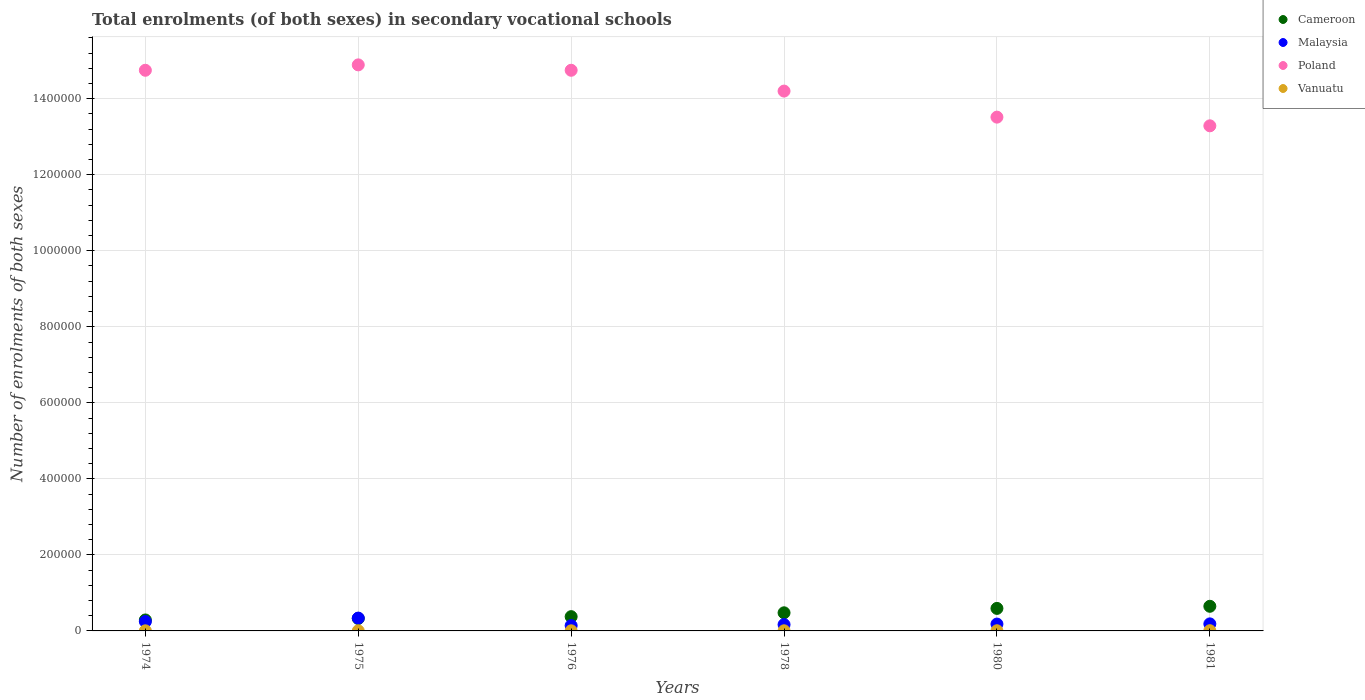How many different coloured dotlines are there?
Make the answer very short. 4. What is the number of enrolments in secondary schools in Poland in 1976?
Give a very brief answer. 1.47e+06. Across all years, what is the maximum number of enrolments in secondary schools in Poland?
Provide a short and direct response. 1.49e+06. Across all years, what is the minimum number of enrolments in secondary schools in Cameroon?
Ensure brevity in your answer.  2.88e+04. In which year was the number of enrolments in secondary schools in Malaysia maximum?
Your response must be concise. 1975. What is the total number of enrolments in secondary schools in Malaysia in the graph?
Provide a succinct answer. 1.26e+05. What is the difference between the number of enrolments in secondary schools in Vanuatu in 1975 and that in 1980?
Offer a very short reply. -214. What is the difference between the number of enrolments in secondary schools in Malaysia in 1981 and the number of enrolments in secondary schools in Cameroon in 1974?
Provide a short and direct response. -1.03e+04. What is the average number of enrolments in secondary schools in Cameroon per year?
Offer a terse response. 4.51e+04. In the year 1978, what is the difference between the number of enrolments in secondary schools in Poland and number of enrolments in secondary schools in Cameroon?
Provide a succinct answer. 1.37e+06. What is the ratio of the number of enrolments in secondary schools in Cameroon in 1978 to that in 1980?
Keep it short and to the point. 0.8. Is the number of enrolments in secondary schools in Malaysia in 1974 less than that in 1976?
Make the answer very short. No. Is the difference between the number of enrolments in secondary schools in Poland in 1975 and 1978 greater than the difference between the number of enrolments in secondary schools in Cameroon in 1975 and 1978?
Your answer should be compact. Yes. What is the difference between the highest and the second highest number of enrolments in secondary schools in Malaysia?
Make the answer very short. 9101. What is the difference between the highest and the lowest number of enrolments in secondary schools in Poland?
Offer a terse response. 1.60e+05. Is the sum of the number of enrolments in secondary schools in Cameroon in 1974 and 1976 greater than the maximum number of enrolments in secondary schools in Vanuatu across all years?
Your answer should be compact. Yes. Is it the case that in every year, the sum of the number of enrolments in secondary schools in Poland and number of enrolments in secondary schools in Malaysia  is greater than the sum of number of enrolments in secondary schools in Vanuatu and number of enrolments in secondary schools in Cameroon?
Offer a terse response. Yes. Does the number of enrolments in secondary schools in Vanuatu monotonically increase over the years?
Your answer should be compact. No. Is the number of enrolments in secondary schools in Cameroon strictly greater than the number of enrolments in secondary schools in Malaysia over the years?
Provide a succinct answer. No. Is the number of enrolments in secondary schools in Vanuatu strictly less than the number of enrolments in secondary schools in Poland over the years?
Provide a succinct answer. Yes. How many dotlines are there?
Give a very brief answer. 4. Does the graph contain any zero values?
Offer a very short reply. No. Does the graph contain grids?
Ensure brevity in your answer.  Yes. Where does the legend appear in the graph?
Your answer should be very brief. Top right. How are the legend labels stacked?
Provide a succinct answer. Vertical. What is the title of the graph?
Provide a short and direct response. Total enrolments (of both sexes) in secondary vocational schools. What is the label or title of the X-axis?
Make the answer very short. Years. What is the label or title of the Y-axis?
Your answer should be compact. Number of enrolments of both sexes. What is the Number of enrolments of both sexes in Cameroon in 1974?
Provide a short and direct response. 2.88e+04. What is the Number of enrolments of both sexes of Malaysia in 1974?
Offer a terse response. 2.46e+04. What is the Number of enrolments of both sexes in Poland in 1974?
Your answer should be compact. 1.47e+06. What is the Number of enrolments of both sexes of Vanuatu in 1974?
Your response must be concise. 279. What is the Number of enrolments of both sexes in Cameroon in 1975?
Provide a succinct answer. 3.27e+04. What is the Number of enrolments of both sexes of Malaysia in 1975?
Provide a short and direct response. 3.37e+04. What is the Number of enrolments of both sexes in Poland in 1975?
Offer a very short reply. 1.49e+06. What is the Number of enrolments of both sexes of Vanuatu in 1975?
Offer a very short reply. 242. What is the Number of enrolments of both sexes of Cameroon in 1976?
Ensure brevity in your answer.  3.75e+04. What is the Number of enrolments of both sexes of Malaysia in 1976?
Give a very brief answer. 1.40e+04. What is the Number of enrolments of both sexes of Poland in 1976?
Provide a short and direct response. 1.47e+06. What is the Number of enrolments of both sexes of Vanuatu in 1976?
Your response must be concise. 308. What is the Number of enrolments of both sexes of Cameroon in 1978?
Your response must be concise. 4.77e+04. What is the Number of enrolments of both sexes of Malaysia in 1978?
Give a very brief answer. 1.67e+04. What is the Number of enrolments of both sexes of Poland in 1978?
Provide a succinct answer. 1.42e+06. What is the Number of enrolments of both sexes of Vanuatu in 1978?
Provide a succinct answer. 363. What is the Number of enrolments of both sexes in Cameroon in 1980?
Provide a short and direct response. 5.92e+04. What is the Number of enrolments of both sexes of Malaysia in 1980?
Provide a succinct answer. 1.80e+04. What is the Number of enrolments of both sexes of Poland in 1980?
Make the answer very short. 1.35e+06. What is the Number of enrolments of both sexes in Vanuatu in 1980?
Your answer should be very brief. 456. What is the Number of enrolments of both sexes of Cameroon in 1981?
Keep it short and to the point. 6.48e+04. What is the Number of enrolments of both sexes in Malaysia in 1981?
Offer a terse response. 1.85e+04. What is the Number of enrolments of both sexes in Poland in 1981?
Provide a short and direct response. 1.33e+06. What is the Number of enrolments of both sexes of Vanuatu in 1981?
Offer a very short reply. 597. Across all years, what is the maximum Number of enrolments of both sexes of Cameroon?
Offer a very short reply. 6.48e+04. Across all years, what is the maximum Number of enrolments of both sexes of Malaysia?
Your answer should be very brief. 3.37e+04. Across all years, what is the maximum Number of enrolments of both sexes in Poland?
Provide a succinct answer. 1.49e+06. Across all years, what is the maximum Number of enrolments of both sexes of Vanuatu?
Ensure brevity in your answer.  597. Across all years, what is the minimum Number of enrolments of both sexes in Cameroon?
Give a very brief answer. 2.88e+04. Across all years, what is the minimum Number of enrolments of both sexes of Malaysia?
Provide a short and direct response. 1.40e+04. Across all years, what is the minimum Number of enrolments of both sexes of Poland?
Provide a short and direct response. 1.33e+06. Across all years, what is the minimum Number of enrolments of both sexes in Vanuatu?
Your answer should be very brief. 242. What is the total Number of enrolments of both sexes of Cameroon in the graph?
Provide a succinct answer. 2.71e+05. What is the total Number of enrolments of both sexes in Malaysia in the graph?
Offer a terse response. 1.26e+05. What is the total Number of enrolments of both sexes of Poland in the graph?
Offer a terse response. 8.54e+06. What is the total Number of enrolments of both sexes in Vanuatu in the graph?
Make the answer very short. 2245. What is the difference between the Number of enrolments of both sexes in Cameroon in 1974 and that in 1975?
Your answer should be compact. -3887. What is the difference between the Number of enrolments of both sexes of Malaysia in 1974 and that in 1975?
Your response must be concise. -9101. What is the difference between the Number of enrolments of both sexes in Poland in 1974 and that in 1975?
Provide a succinct answer. -1.42e+04. What is the difference between the Number of enrolments of both sexes of Cameroon in 1974 and that in 1976?
Keep it short and to the point. -8713. What is the difference between the Number of enrolments of both sexes in Malaysia in 1974 and that in 1976?
Your response must be concise. 1.06e+04. What is the difference between the Number of enrolments of both sexes of Cameroon in 1974 and that in 1978?
Your response must be concise. -1.88e+04. What is the difference between the Number of enrolments of both sexes in Malaysia in 1974 and that in 1978?
Your answer should be very brief. 7990. What is the difference between the Number of enrolments of both sexes of Poland in 1974 and that in 1978?
Keep it short and to the point. 5.48e+04. What is the difference between the Number of enrolments of both sexes in Vanuatu in 1974 and that in 1978?
Give a very brief answer. -84. What is the difference between the Number of enrolments of both sexes of Cameroon in 1974 and that in 1980?
Your answer should be compact. -3.04e+04. What is the difference between the Number of enrolments of both sexes of Malaysia in 1974 and that in 1980?
Offer a very short reply. 6610. What is the difference between the Number of enrolments of both sexes in Poland in 1974 and that in 1980?
Ensure brevity in your answer.  1.23e+05. What is the difference between the Number of enrolments of both sexes in Vanuatu in 1974 and that in 1980?
Your answer should be very brief. -177. What is the difference between the Number of enrolments of both sexes of Cameroon in 1974 and that in 1981?
Ensure brevity in your answer.  -3.60e+04. What is the difference between the Number of enrolments of both sexes in Malaysia in 1974 and that in 1981?
Your answer should be very brief. 6120. What is the difference between the Number of enrolments of both sexes in Poland in 1974 and that in 1981?
Keep it short and to the point. 1.46e+05. What is the difference between the Number of enrolments of both sexes in Vanuatu in 1974 and that in 1981?
Offer a very short reply. -318. What is the difference between the Number of enrolments of both sexes in Cameroon in 1975 and that in 1976?
Your answer should be compact. -4826. What is the difference between the Number of enrolments of both sexes of Malaysia in 1975 and that in 1976?
Provide a short and direct response. 1.97e+04. What is the difference between the Number of enrolments of both sexes of Poland in 1975 and that in 1976?
Keep it short and to the point. 1.42e+04. What is the difference between the Number of enrolments of both sexes of Vanuatu in 1975 and that in 1976?
Offer a very short reply. -66. What is the difference between the Number of enrolments of both sexes of Cameroon in 1975 and that in 1978?
Provide a short and direct response. -1.49e+04. What is the difference between the Number of enrolments of both sexes in Malaysia in 1975 and that in 1978?
Give a very brief answer. 1.71e+04. What is the difference between the Number of enrolments of both sexes in Poland in 1975 and that in 1978?
Offer a very short reply. 6.90e+04. What is the difference between the Number of enrolments of both sexes in Vanuatu in 1975 and that in 1978?
Ensure brevity in your answer.  -121. What is the difference between the Number of enrolments of both sexes in Cameroon in 1975 and that in 1980?
Ensure brevity in your answer.  -2.65e+04. What is the difference between the Number of enrolments of both sexes in Malaysia in 1975 and that in 1980?
Keep it short and to the point. 1.57e+04. What is the difference between the Number of enrolments of both sexes in Poland in 1975 and that in 1980?
Offer a terse response. 1.37e+05. What is the difference between the Number of enrolments of both sexes of Vanuatu in 1975 and that in 1980?
Give a very brief answer. -214. What is the difference between the Number of enrolments of both sexes of Cameroon in 1975 and that in 1981?
Your response must be concise. -3.21e+04. What is the difference between the Number of enrolments of both sexes of Malaysia in 1975 and that in 1981?
Make the answer very short. 1.52e+04. What is the difference between the Number of enrolments of both sexes of Poland in 1975 and that in 1981?
Your answer should be very brief. 1.60e+05. What is the difference between the Number of enrolments of both sexes in Vanuatu in 1975 and that in 1981?
Offer a very short reply. -355. What is the difference between the Number of enrolments of both sexes in Cameroon in 1976 and that in 1978?
Your answer should be compact. -1.01e+04. What is the difference between the Number of enrolments of both sexes in Malaysia in 1976 and that in 1978?
Provide a succinct answer. -2651. What is the difference between the Number of enrolments of both sexes in Poland in 1976 and that in 1978?
Provide a short and direct response. 5.48e+04. What is the difference between the Number of enrolments of both sexes in Vanuatu in 1976 and that in 1978?
Give a very brief answer. -55. What is the difference between the Number of enrolments of both sexes of Cameroon in 1976 and that in 1980?
Your response must be concise. -2.17e+04. What is the difference between the Number of enrolments of both sexes in Malaysia in 1976 and that in 1980?
Keep it short and to the point. -4031. What is the difference between the Number of enrolments of both sexes of Poland in 1976 and that in 1980?
Your answer should be very brief. 1.23e+05. What is the difference between the Number of enrolments of both sexes in Vanuatu in 1976 and that in 1980?
Ensure brevity in your answer.  -148. What is the difference between the Number of enrolments of both sexes in Cameroon in 1976 and that in 1981?
Your answer should be compact. -2.72e+04. What is the difference between the Number of enrolments of both sexes of Malaysia in 1976 and that in 1981?
Provide a succinct answer. -4521. What is the difference between the Number of enrolments of both sexes in Poland in 1976 and that in 1981?
Offer a very short reply. 1.46e+05. What is the difference between the Number of enrolments of both sexes in Vanuatu in 1976 and that in 1981?
Give a very brief answer. -289. What is the difference between the Number of enrolments of both sexes of Cameroon in 1978 and that in 1980?
Keep it short and to the point. -1.16e+04. What is the difference between the Number of enrolments of both sexes in Malaysia in 1978 and that in 1980?
Offer a very short reply. -1380. What is the difference between the Number of enrolments of both sexes in Poland in 1978 and that in 1980?
Provide a succinct answer. 6.85e+04. What is the difference between the Number of enrolments of both sexes in Vanuatu in 1978 and that in 1980?
Offer a terse response. -93. What is the difference between the Number of enrolments of both sexes in Cameroon in 1978 and that in 1981?
Offer a very short reply. -1.71e+04. What is the difference between the Number of enrolments of both sexes of Malaysia in 1978 and that in 1981?
Your response must be concise. -1870. What is the difference between the Number of enrolments of both sexes of Poland in 1978 and that in 1981?
Your response must be concise. 9.14e+04. What is the difference between the Number of enrolments of both sexes in Vanuatu in 1978 and that in 1981?
Keep it short and to the point. -234. What is the difference between the Number of enrolments of both sexes of Cameroon in 1980 and that in 1981?
Your answer should be compact. -5550. What is the difference between the Number of enrolments of both sexes of Malaysia in 1980 and that in 1981?
Provide a succinct answer. -490. What is the difference between the Number of enrolments of both sexes in Poland in 1980 and that in 1981?
Give a very brief answer. 2.28e+04. What is the difference between the Number of enrolments of both sexes of Vanuatu in 1980 and that in 1981?
Ensure brevity in your answer.  -141. What is the difference between the Number of enrolments of both sexes in Cameroon in 1974 and the Number of enrolments of both sexes in Malaysia in 1975?
Keep it short and to the point. -4909. What is the difference between the Number of enrolments of both sexes of Cameroon in 1974 and the Number of enrolments of both sexes of Poland in 1975?
Your response must be concise. -1.46e+06. What is the difference between the Number of enrolments of both sexes in Cameroon in 1974 and the Number of enrolments of both sexes in Vanuatu in 1975?
Keep it short and to the point. 2.86e+04. What is the difference between the Number of enrolments of both sexes in Malaysia in 1974 and the Number of enrolments of both sexes in Poland in 1975?
Keep it short and to the point. -1.46e+06. What is the difference between the Number of enrolments of both sexes of Malaysia in 1974 and the Number of enrolments of both sexes of Vanuatu in 1975?
Your answer should be very brief. 2.44e+04. What is the difference between the Number of enrolments of both sexes in Poland in 1974 and the Number of enrolments of both sexes in Vanuatu in 1975?
Give a very brief answer. 1.47e+06. What is the difference between the Number of enrolments of both sexes in Cameroon in 1974 and the Number of enrolments of both sexes in Malaysia in 1976?
Your answer should be very brief. 1.48e+04. What is the difference between the Number of enrolments of both sexes in Cameroon in 1974 and the Number of enrolments of both sexes in Poland in 1976?
Offer a very short reply. -1.45e+06. What is the difference between the Number of enrolments of both sexes in Cameroon in 1974 and the Number of enrolments of both sexes in Vanuatu in 1976?
Provide a short and direct response. 2.85e+04. What is the difference between the Number of enrolments of both sexes of Malaysia in 1974 and the Number of enrolments of both sexes of Poland in 1976?
Keep it short and to the point. -1.45e+06. What is the difference between the Number of enrolments of both sexes in Malaysia in 1974 and the Number of enrolments of both sexes in Vanuatu in 1976?
Your response must be concise. 2.43e+04. What is the difference between the Number of enrolments of both sexes of Poland in 1974 and the Number of enrolments of both sexes of Vanuatu in 1976?
Provide a short and direct response. 1.47e+06. What is the difference between the Number of enrolments of both sexes in Cameroon in 1974 and the Number of enrolments of both sexes in Malaysia in 1978?
Your answer should be very brief. 1.22e+04. What is the difference between the Number of enrolments of both sexes of Cameroon in 1974 and the Number of enrolments of both sexes of Poland in 1978?
Your answer should be very brief. -1.39e+06. What is the difference between the Number of enrolments of both sexes of Cameroon in 1974 and the Number of enrolments of both sexes of Vanuatu in 1978?
Your answer should be very brief. 2.85e+04. What is the difference between the Number of enrolments of both sexes in Malaysia in 1974 and the Number of enrolments of both sexes in Poland in 1978?
Your answer should be very brief. -1.40e+06. What is the difference between the Number of enrolments of both sexes in Malaysia in 1974 and the Number of enrolments of both sexes in Vanuatu in 1978?
Your answer should be very brief. 2.43e+04. What is the difference between the Number of enrolments of both sexes of Poland in 1974 and the Number of enrolments of both sexes of Vanuatu in 1978?
Your response must be concise. 1.47e+06. What is the difference between the Number of enrolments of both sexes in Cameroon in 1974 and the Number of enrolments of both sexes in Malaysia in 1980?
Make the answer very short. 1.08e+04. What is the difference between the Number of enrolments of both sexes in Cameroon in 1974 and the Number of enrolments of both sexes in Poland in 1980?
Give a very brief answer. -1.32e+06. What is the difference between the Number of enrolments of both sexes in Cameroon in 1974 and the Number of enrolments of both sexes in Vanuatu in 1980?
Make the answer very short. 2.84e+04. What is the difference between the Number of enrolments of both sexes of Malaysia in 1974 and the Number of enrolments of both sexes of Poland in 1980?
Provide a short and direct response. -1.33e+06. What is the difference between the Number of enrolments of both sexes in Malaysia in 1974 and the Number of enrolments of both sexes in Vanuatu in 1980?
Provide a succinct answer. 2.42e+04. What is the difference between the Number of enrolments of both sexes of Poland in 1974 and the Number of enrolments of both sexes of Vanuatu in 1980?
Provide a short and direct response. 1.47e+06. What is the difference between the Number of enrolments of both sexes in Cameroon in 1974 and the Number of enrolments of both sexes in Malaysia in 1981?
Provide a short and direct response. 1.03e+04. What is the difference between the Number of enrolments of both sexes of Cameroon in 1974 and the Number of enrolments of both sexes of Poland in 1981?
Give a very brief answer. -1.30e+06. What is the difference between the Number of enrolments of both sexes in Cameroon in 1974 and the Number of enrolments of both sexes in Vanuatu in 1981?
Ensure brevity in your answer.  2.82e+04. What is the difference between the Number of enrolments of both sexes in Malaysia in 1974 and the Number of enrolments of both sexes in Poland in 1981?
Your answer should be compact. -1.30e+06. What is the difference between the Number of enrolments of both sexes in Malaysia in 1974 and the Number of enrolments of both sexes in Vanuatu in 1981?
Provide a succinct answer. 2.40e+04. What is the difference between the Number of enrolments of both sexes of Poland in 1974 and the Number of enrolments of both sexes of Vanuatu in 1981?
Offer a very short reply. 1.47e+06. What is the difference between the Number of enrolments of both sexes of Cameroon in 1975 and the Number of enrolments of both sexes of Malaysia in 1976?
Provide a short and direct response. 1.87e+04. What is the difference between the Number of enrolments of both sexes in Cameroon in 1975 and the Number of enrolments of both sexes in Poland in 1976?
Provide a succinct answer. -1.44e+06. What is the difference between the Number of enrolments of both sexes in Cameroon in 1975 and the Number of enrolments of both sexes in Vanuatu in 1976?
Your answer should be very brief. 3.24e+04. What is the difference between the Number of enrolments of both sexes of Malaysia in 1975 and the Number of enrolments of both sexes of Poland in 1976?
Keep it short and to the point. -1.44e+06. What is the difference between the Number of enrolments of both sexes of Malaysia in 1975 and the Number of enrolments of both sexes of Vanuatu in 1976?
Give a very brief answer. 3.34e+04. What is the difference between the Number of enrolments of both sexes in Poland in 1975 and the Number of enrolments of both sexes in Vanuatu in 1976?
Provide a succinct answer. 1.49e+06. What is the difference between the Number of enrolments of both sexes of Cameroon in 1975 and the Number of enrolments of both sexes of Malaysia in 1978?
Your answer should be very brief. 1.61e+04. What is the difference between the Number of enrolments of both sexes in Cameroon in 1975 and the Number of enrolments of both sexes in Poland in 1978?
Offer a terse response. -1.39e+06. What is the difference between the Number of enrolments of both sexes in Cameroon in 1975 and the Number of enrolments of both sexes in Vanuatu in 1978?
Provide a succinct answer. 3.24e+04. What is the difference between the Number of enrolments of both sexes of Malaysia in 1975 and the Number of enrolments of both sexes of Poland in 1978?
Make the answer very short. -1.39e+06. What is the difference between the Number of enrolments of both sexes of Malaysia in 1975 and the Number of enrolments of both sexes of Vanuatu in 1978?
Ensure brevity in your answer.  3.34e+04. What is the difference between the Number of enrolments of both sexes of Poland in 1975 and the Number of enrolments of both sexes of Vanuatu in 1978?
Make the answer very short. 1.49e+06. What is the difference between the Number of enrolments of both sexes in Cameroon in 1975 and the Number of enrolments of both sexes in Malaysia in 1980?
Your response must be concise. 1.47e+04. What is the difference between the Number of enrolments of both sexes of Cameroon in 1975 and the Number of enrolments of both sexes of Poland in 1980?
Provide a short and direct response. -1.32e+06. What is the difference between the Number of enrolments of both sexes in Cameroon in 1975 and the Number of enrolments of both sexes in Vanuatu in 1980?
Offer a terse response. 3.23e+04. What is the difference between the Number of enrolments of both sexes of Malaysia in 1975 and the Number of enrolments of both sexes of Poland in 1980?
Offer a terse response. -1.32e+06. What is the difference between the Number of enrolments of both sexes in Malaysia in 1975 and the Number of enrolments of both sexes in Vanuatu in 1980?
Provide a short and direct response. 3.33e+04. What is the difference between the Number of enrolments of both sexes in Poland in 1975 and the Number of enrolments of both sexes in Vanuatu in 1980?
Provide a succinct answer. 1.49e+06. What is the difference between the Number of enrolments of both sexes of Cameroon in 1975 and the Number of enrolments of both sexes of Malaysia in 1981?
Your answer should be compact. 1.42e+04. What is the difference between the Number of enrolments of both sexes in Cameroon in 1975 and the Number of enrolments of both sexes in Poland in 1981?
Give a very brief answer. -1.30e+06. What is the difference between the Number of enrolments of both sexes of Cameroon in 1975 and the Number of enrolments of both sexes of Vanuatu in 1981?
Provide a succinct answer. 3.21e+04. What is the difference between the Number of enrolments of both sexes of Malaysia in 1975 and the Number of enrolments of both sexes of Poland in 1981?
Offer a very short reply. -1.29e+06. What is the difference between the Number of enrolments of both sexes in Malaysia in 1975 and the Number of enrolments of both sexes in Vanuatu in 1981?
Your response must be concise. 3.31e+04. What is the difference between the Number of enrolments of both sexes in Poland in 1975 and the Number of enrolments of both sexes in Vanuatu in 1981?
Your response must be concise. 1.49e+06. What is the difference between the Number of enrolments of both sexes of Cameroon in 1976 and the Number of enrolments of both sexes of Malaysia in 1978?
Give a very brief answer. 2.09e+04. What is the difference between the Number of enrolments of both sexes of Cameroon in 1976 and the Number of enrolments of both sexes of Poland in 1978?
Provide a succinct answer. -1.38e+06. What is the difference between the Number of enrolments of both sexes of Cameroon in 1976 and the Number of enrolments of both sexes of Vanuatu in 1978?
Your answer should be compact. 3.72e+04. What is the difference between the Number of enrolments of both sexes of Malaysia in 1976 and the Number of enrolments of both sexes of Poland in 1978?
Offer a terse response. -1.41e+06. What is the difference between the Number of enrolments of both sexes of Malaysia in 1976 and the Number of enrolments of both sexes of Vanuatu in 1978?
Give a very brief answer. 1.36e+04. What is the difference between the Number of enrolments of both sexes in Poland in 1976 and the Number of enrolments of both sexes in Vanuatu in 1978?
Offer a terse response. 1.47e+06. What is the difference between the Number of enrolments of both sexes of Cameroon in 1976 and the Number of enrolments of both sexes of Malaysia in 1980?
Provide a succinct answer. 1.95e+04. What is the difference between the Number of enrolments of both sexes in Cameroon in 1976 and the Number of enrolments of both sexes in Poland in 1980?
Offer a very short reply. -1.31e+06. What is the difference between the Number of enrolments of both sexes of Cameroon in 1976 and the Number of enrolments of both sexes of Vanuatu in 1980?
Offer a very short reply. 3.71e+04. What is the difference between the Number of enrolments of both sexes of Malaysia in 1976 and the Number of enrolments of both sexes of Poland in 1980?
Offer a very short reply. -1.34e+06. What is the difference between the Number of enrolments of both sexes of Malaysia in 1976 and the Number of enrolments of both sexes of Vanuatu in 1980?
Keep it short and to the point. 1.35e+04. What is the difference between the Number of enrolments of both sexes of Poland in 1976 and the Number of enrolments of both sexes of Vanuatu in 1980?
Your answer should be compact. 1.47e+06. What is the difference between the Number of enrolments of both sexes in Cameroon in 1976 and the Number of enrolments of both sexes in Malaysia in 1981?
Make the answer very short. 1.90e+04. What is the difference between the Number of enrolments of both sexes in Cameroon in 1976 and the Number of enrolments of both sexes in Poland in 1981?
Make the answer very short. -1.29e+06. What is the difference between the Number of enrolments of both sexes in Cameroon in 1976 and the Number of enrolments of both sexes in Vanuatu in 1981?
Provide a succinct answer. 3.69e+04. What is the difference between the Number of enrolments of both sexes in Malaysia in 1976 and the Number of enrolments of both sexes in Poland in 1981?
Your answer should be compact. -1.31e+06. What is the difference between the Number of enrolments of both sexes of Malaysia in 1976 and the Number of enrolments of both sexes of Vanuatu in 1981?
Provide a succinct answer. 1.34e+04. What is the difference between the Number of enrolments of both sexes of Poland in 1976 and the Number of enrolments of both sexes of Vanuatu in 1981?
Make the answer very short. 1.47e+06. What is the difference between the Number of enrolments of both sexes of Cameroon in 1978 and the Number of enrolments of both sexes of Malaysia in 1980?
Your answer should be very brief. 2.96e+04. What is the difference between the Number of enrolments of both sexes in Cameroon in 1978 and the Number of enrolments of both sexes in Poland in 1980?
Provide a short and direct response. -1.30e+06. What is the difference between the Number of enrolments of both sexes of Cameroon in 1978 and the Number of enrolments of both sexes of Vanuatu in 1980?
Keep it short and to the point. 4.72e+04. What is the difference between the Number of enrolments of both sexes in Malaysia in 1978 and the Number of enrolments of both sexes in Poland in 1980?
Ensure brevity in your answer.  -1.33e+06. What is the difference between the Number of enrolments of both sexes of Malaysia in 1978 and the Number of enrolments of both sexes of Vanuatu in 1980?
Offer a very short reply. 1.62e+04. What is the difference between the Number of enrolments of both sexes of Poland in 1978 and the Number of enrolments of both sexes of Vanuatu in 1980?
Provide a short and direct response. 1.42e+06. What is the difference between the Number of enrolments of both sexes of Cameroon in 1978 and the Number of enrolments of both sexes of Malaysia in 1981?
Ensure brevity in your answer.  2.91e+04. What is the difference between the Number of enrolments of both sexes of Cameroon in 1978 and the Number of enrolments of both sexes of Poland in 1981?
Offer a very short reply. -1.28e+06. What is the difference between the Number of enrolments of both sexes in Cameroon in 1978 and the Number of enrolments of both sexes in Vanuatu in 1981?
Provide a succinct answer. 4.71e+04. What is the difference between the Number of enrolments of both sexes of Malaysia in 1978 and the Number of enrolments of both sexes of Poland in 1981?
Ensure brevity in your answer.  -1.31e+06. What is the difference between the Number of enrolments of both sexes of Malaysia in 1978 and the Number of enrolments of both sexes of Vanuatu in 1981?
Your answer should be compact. 1.61e+04. What is the difference between the Number of enrolments of both sexes in Poland in 1978 and the Number of enrolments of both sexes in Vanuatu in 1981?
Your answer should be compact. 1.42e+06. What is the difference between the Number of enrolments of both sexes of Cameroon in 1980 and the Number of enrolments of both sexes of Malaysia in 1981?
Make the answer very short. 4.07e+04. What is the difference between the Number of enrolments of both sexes in Cameroon in 1980 and the Number of enrolments of both sexes in Poland in 1981?
Your answer should be compact. -1.27e+06. What is the difference between the Number of enrolments of both sexes in Cameroon in 1980 and the Number of enrolments of both sexes in Vanuatu in 1981?
Offer a terse response. 5.86e+04. What is the difference between the Number of enrolments of both sexes in Malaysia in 1980 and the Number of enrolments of both sexes in Poland in 1981?
Make the answer very short. -1.31e+06. What is the difference between the Number of enrolments of both sexes of Malaysia in 1980 and the Number of enrolments of both sexes of Vanuatu in 1981?
Keep it short and to the point. 1.74e+04. What is the difference between the Number of enrolments of both sexes in Poland in 1980 and the Number of enrolments of both sexes in Vanuatu in 1981?
Make the answer very short. 1.35e+06. What is the average Number of enrolments of both sexes of Cameroon per year?
Offer a terse response. 4.51e+04. What is the average Number of enrolments of both sexes of Malaysia per year?
Your response must be concise. 2.09e+04. What is the average Number of enrolments of both sexes of Poland per year?
Give a very brief answer. 1.42e+06. What is the average Number of enrolments of both sexes in Vanuatu per year?
Provide a succinct answer. 374.17. In the year 1974, what is the difference between the Number of enrolments of both sexes in Cameroon and Number of enrolments of both sexes in Malaysia?
Offer a very short reply. 4192. In the year 1974, what is the difference between the Number of enrolments of both sexes in Cameroon and Number of enrolments of both sexes in Poland?
Give a very brief answer. -1.45e+06. In the year 1974, what is the difference between the Number of enrolments of both sexes of Cameroon and Number of enrolments of both sexes of Vanuatu?
Your answer should be very brief. 2.86e+04. In the year 1974, what is the difference between the Number of enrolments of both sexes in Malaysia and Number of enrolments of both sexes in Poland?
Your response must be concise. -1.45e+06. In the year 1974, what is the difference between the Number of enrolments of both sexes in Malaysia and Number of enrolments of both sexes in Vanuatu?
Your response must be concise. 2.44e+04. In the year 1974, what is the difference between the Number of enrolments of both sexes in Poland and Number of enrolments of both sexes in Vanuatu?
Keep it short and to the point. 1.47e+06. In the year 1975, what is the difference between the Number of enrolments of both sexes in Cameroon and Number of enrolments of both sexes in Malaysia?
Keep it short and to the point. -1022. In the year 1975, what is the difference between the Number of enrolments of both sexes of Cameroon and Number of enrolments of both sexes of Poland?
Your answer should be compact. -1.46e+06. In the year 1975, what is the difference between the Number of enrolments of both sexes in Cameroon and Number of enrolments of both sexes in Vanuatu?
Offer a very short reply. 3.25e+04. In the year 1975, what is the difference between the Number of enrolments of both sexes in Malaysia and Number of enrolments of both sexes in Poland?
Keep it short and to the point. -1.46e+06. In the year 1975, what is the difference between the Number of enrolments of both sexes of Malaysia and Number of enrolments of both sexes of Vanuatu?
Provide a succinct answer. 3.35e+04. In the year 1975, what is the difference between the Number of enrolments of both sexes in Poland and Number of enrolments of both sexes in Vanuatu?
Provide a succinct answer. 1.49e+06. In the year 1976, what is the difference between the Number of enrolments of both sexes of Cameroon and Number of enrolments of both sexes of Malaysia?
Provide a succinct answer. 2.35e+04. In the year 1976, what is the difference between the Number of enrolments of both sexes in Cameroon and Number of enrolments of both sexes in Poland?
Provide a short and direct response. -1.44e+06. In the year 1976, what is the difference between the Number of enrolments of both sexes of Cameroon and Number of enrolments of both sexes of Vanuatu?
Provide a succinct answer. 3.72e+04. In the year 1976, what is the difference between the Number of enrolments of both sexes of Malaysia and Number of enrolments of both sexes of Poland?
Your response must be concise. -1.46e+06. In the year 1976, what is the difference between the Number of enrolments of both sexes of Malaysia and Number of enrolments of both sexes of Vanuatu?
Give a very brief answer. 1.37e+04. In the year 1976, what is the difference between the Number of enrolments of both sexes of Poland and Number of enrolments of both sexes of Vanuatu?
Make the answer very short. 1.47e+06. In the year 1978, what is the difference between the Number of enrolments of both sexes in Cameroon and Number of enrolments of both sexes in Malaysia?
Keep it short and to the point. 3.10e+04. In the year 1978, what is the difference between the Number of enrolments of both sexes of Cameroon and Number of enrolments of both sexes of Poland?
Offer a very short reply. -1.37e+06. In the year 1978, what is the difference between the Number of enrolments of both sexes of Cameroon and Number of enrolments of both sexes of Vanuatu?
Make the answer very short. 4.73e+04. In the year 1978, what is the difference between the Number of enrolments of both sexes in Malaysia and Number of enrolments of both sexes in Poland?
Offer a very short reply. -1.40e+06. In the year 1978, what is the difference between the Number of enrolments of both sexes in Malaysia and Number of enrolments of both sexes in Vanuatu?
Make the answer very short. 1.63e+04. In the year 1978, what is the difference between the Number of enrolments of both sexes in Poland and Number of enrolments of both sexes in Vanuatu?
Ensure brevity in your answer.  1.42e+06. In the year 1980, what is the difference between the Number of enrolments of both sexes in Cameroon and Number of enrolments of both sexes in Malaysia?
Ensure brevity in your answer.  4.12e+04. In the year 1980, what is the difference between the Number of enrolments of both sexes of Cameroon and Number of enrolments of both sexes of Poland?
Offer a very short reply. -1.29e+06. In the year 1980, what is the difference between the Number of enrolments of both sexes of Cameroon and Number of enrolments of both sexes of Vanuatu?
Provide a short and direct response. 5.88e+04. In the year 1980, what is the difference between the Number of enrolments of both sexes of Malaysia and Number of enrolments of both sexes of Poland?
Give a very brief answer. -1.33e+06. In the year 1980, what is the difference between the Number of enrolments of both sexes in Malaysia and Number of enrolments of both sexes in Vanuatu?
Offer a very short reply. 1.76e+04. In the year 1980, what is the difference between the Number of enrolments of both sexes in Poland and Number of enrolments of both sexes in Vanuatu?
Your response must be concise. 1.35e+06. In the year 1981, what is the difference between the Number of enrolments of both sexes of Cameroon and Number of enrolments of both sexes of Malaysia?
Offer a very short reply. 4.63e+04. In the year 1981, what is the difference between the Number of enrolments of both sexes in Cameroon and Number of enrolments of both sexes in Poland?
Keep it short and to the point. -1.26e+06. In the year 1981, what is the difference between the Number of enrolments of both sexes of Cameroon and Number of enrolments of both sexes of Vanuatu?
Ensure brevity in your answer.  6.42e+04. In the year 1981, what is the difference between the Number of enrolments of both sexes in Malaysia and Number of enrolments of both sexes in Poland?
Keep it short and to the point. -1.31e+06. In the year 1981, what is the difference between the Number of enrolments of both sexes in Malaysia and Number of enrolments of both sexes in Vanuatu?
Your answer should be compact. 1.79e+04. In the year 1981, what is the difference between the Number of enrolments of both sexes of Poland and Number of enrolments of both sexes of Vanuatu?
Your answer should be very brief. 1.33e+06. What is the ratio of the Number of enrolments of both sexes in Cameroon in 1974 to that in 1975?
Keep it short and to the point. 0.88. What is the ratio of the Number of enrolments of both sexes in Malaysia in 1974 to that in 1975?
Offer a very short reply. 0.73. What is the ratio of the Number of enrolments of both sexes of Vanuatu in 1974 to that in 1975?
Keep it short and to the point. 1.15. What is the ratio of the Number of enrolments of both sexes of Cameroon in 1974 to that in 1976?
Give a very brief answer. 0.77. What is the ratio of the Number of enrolments of both sexes in Malaysia in 1974 to that in 1976?
Your answer should be very brief. 1.76. What is the ratio of the Number of enrolments of both sexes of Vanuatu in 1974 to that in 1976?
Offer a terse response. 0.91. What is the ratio of the Number of enrolments of both sexes of Cameroon in 1974 to that in 1978?
Ensure brevity in your answer.  0.6. What is the ratio of the Number of enrolments of both sexes of Malaysia in 1974 to that in 1978?
Provide a succinct answer. 1.48. What is the ratio of the Number of enrolments of both sexes of Poland in 1974 to that in 1978?
Give a very brief answer. 1.04. What is the ratio of the Number of enrolments of both sexes in Vanuatu in 1974 to that in 1978?
Make the answer very short. 0.77. What is the ratio of the Number of enrolments of both sexes in Cameroon in 1974 to that in 1980?
Offer a very short reply. 0.49. What is the ratio of the Number of enrolments of both sexes in Malaysia in 1974 to that in 1980?
Ensure brevity in your answer.  1.37. What is the ratio of the Number of enrolments of both sexes of Poland in 1974 to that in 1980?
Make the answer very short. 1.09. What is the ratio of the Number of enrolments of both sexes of Vanuatu in 1974 to that in 1980?
Your answer should be very brief. 0.61. What is the ratio of the Number of enrolments of both sexes in Cameroon in 1974 to that in 1981?
Provide a short and direct response. 0.45. What is the ratio of the Number of enrolments of both sexes of Malaysia in 1974 to that in 1981?
Your answer should be very brief. 1.33. What is the ratio of the Number of enrolments of both sexes in Poland in 1974 to that in 1981?
Keep it short and to the point. 1.11. What is the ratio of the Number of enrolments of both sexes of Vanuatu in 1974 to that in 1981?
Keep it short and to the point. 0.47. What is the ratio of the Number of enrolments of both sexes of Cameroon in 1975 to that in 1976?
Keep it short and to the point. 0.87. What is the ratio of the Number of enrolments of both sexes in Malaysia in 1975 to that in 1976?
Offer a very short reply. 2.41. What is the ratio of the Number of enrolments of both sexes in Poland in 1975 to that in 1976?
Offer a terse response. 1.01. What is the ratio of the Number of enrolments of both sexes of Vanuatu in 1975 to that in 1976?
Offer a terse response. 0.79. What is the ratio of the Number of enrolments of both sexes in Cameroon in 1975 to that in 1978?
Offer a terse response. 0.69. What is the ratio of the Number of enrolments of both sexes of Malaysia in 1975 to that in 1978?
Offer a very short reply. 2.03. What is the ratio of the Number of enrolments of both sexes in Poland in 1975 to that in 1978?
Keep it short and to the point. 1.05. What is the ratio of the Number of enrolments of both sexes of Cameroon in 1975 to that in 1980?
Give a very brief answer. 0.55. What is the ratio of the Number of enrolments of both sexes in Malaysia in 1975 to that in 1980?
Provide a short and direct response. 1.87. What is the ratio of the Number of enrolments of both sexes of Poland in 1975 to that in 1980?
Offer a very short reply. 1.1. What is the ratio of the Number of enrolments of both sexes in Vanuatu in 1975 to that in 1980?
Your response must be concise. 0.53. What is the ratio of the Number of enrolments of both sexes in Cameroon in 1975 to that in 1981?
Provide a short and direct response. 0.51. What is the ratio of the Number of enrolments of both sexes in Malaysia in 1975 to that in 1981?
Your answer should be very brief. 1.82. What is the ratio of the Number of enrolments of both sexes in Poland in 1975 to that in 1981?
Provide a succinct answer. 1.12. What is the ratio of the Number of enrolments of both sexes of Vanuatu in 1975 to that in 1981?
Keep it short and to the point. 0.41. What is the ratio of the Number of enrolments of both sexes in Cameroon in 1976 to that in 1978?
Make the answer very short. 0.79. What is the ratio of the Number of enrolments of both sexes of Malaysia in 1976 to that in 1978?
Provide a succinct answer. 0.84. What is the ratio of the Number of enrolments of both sexes of Poland in 1976 to that in 1978?
Your answer should be very brief. 1.04. What is the ratio of the Number of enrolments of both sexes of Vanuatu in 1976 to that in 1978?
Offer a very short reply. 0.85. What is the ratio of the Number of enrolments of both sexes in Cameroon in 1976 to that in 1980?
Your answer should be compact. 0.63. What is the ratio of the Number of enrolments of both sexes of Malaysia in 1976 to that in 1980?
Make the answer very short. 0.78. What is the ratio of the Number of enrolments of both sexes in Poland in 1976 to that in 1980?
Offer a terse response. 1.09. What is the ratio of the Number of enrolments of both sexes of Vanuatu in 1976 to that in 1980?
Your response must be concise. 0.68. What is the ratio of the Number of enrolments of both sexes in Cameroon in 1976 to that in 1981?
Your answer should be compact. 0.58. What is the ratio of the Number of enrolments of both sexes of Malaysia in 1976 to that in 1981?
Your answer should be very brief. 0.76. What is the ratio of the Number of enrolments of both sexes of Poland in 1976 to that in 1981?
Your answer should be compact. 1.11. What is the ratio of the Number of enrolments of both sexes in Vanuatu in 1976 to that in 1981?
Give a very brief answer. 0.52. What is the ratio of the Number of enrolments of both sexes of Cameroon in 1978 to that in 1980?
Provide a short and direct response. 0.8. What is the ratio of the Number of enrolments of both sexes in Malaysia in 1978 to that in 1980?
Provide a short and direct response. 0.92. What is the ratio of the Number of enrolments of both sexes in Poland in 1978 to that in 1980?
Make the answer very short. 1.05. What is the ratio of the Number of enrolments of both sexes in Vanuatu in 1978 to that in 1980?
Provide a succinct answer. 0.8. What is the ratio of the Number of enrolments of both sexes in Cameroon in 1978 to that in 1981?
Ensure brevity in your answer.  0.74. What is the ratio of the Number of enrolments of both sexes in Malaysia in 1978 to that in 1981?
Give a very brief answer. 0.9. What is the ratio of the Number of enrolments of both sexes of Poland in 1978 to that in 1981?
Make the answer very short. 1.07. What is the ratio of the Number of enrolments of both sexes in Vanuatu in 1978 to that in 1981?
Your response must be concise. 0.61. What is the ratio of the Number of enrolments of both sexes of Cameroon in 1980 to that in 1981?
Your answer should be very brief. 0.91. What is the ratio of the Number of enrolments of both sexes in Malaysia in 1980 to that in 1981?
Offer a very short reply. 0.97. What is the ratio of the Number of enrolments of both sexes of Poland in 1980 to that in 1981?
Ensure brevity in your answer.  1.02. What is the ratio of the Number of enrolments of both sexes in Vanuatu in 1980 to that in 1981?
Provide a short and direct response. 0.76. What is the difference between the highest and the second highest Number of enrolments of both sexes in Cameroon?
Make the answer very short. 5550. What is the difference between the highest and the second highest Number of enrolments of both sexes of Malaysia?
Provide a short and direct response. 9101. What is the difference between the highest and the second highest Number of enrolments of both sexes of Poland?
Provide a succinct answer. 1.42e+04. What is the difference between the highest and the second highest Number of enrolments of both sexes of Vanuatu?
Your answer should be compact. 141. What is the difference between the highest and the lowest Number of enrolments of both sexes of Cameroon?
Keep it short and to the point. 3.60e+04. What is the difference between the highest and the lowest Number of enrolments of both sexes in Malaysia?
Keep it short and to the point. 1.97e+04. What is the difference between the highest and the lowest Number of enrolments of both sexes in Poland?
Your response must be concise. 1.60e+05. What is the difference between the highest and the lowest Number of enrolments of both sexes in Vanuatu?
Keep it short and to the point. 355. 